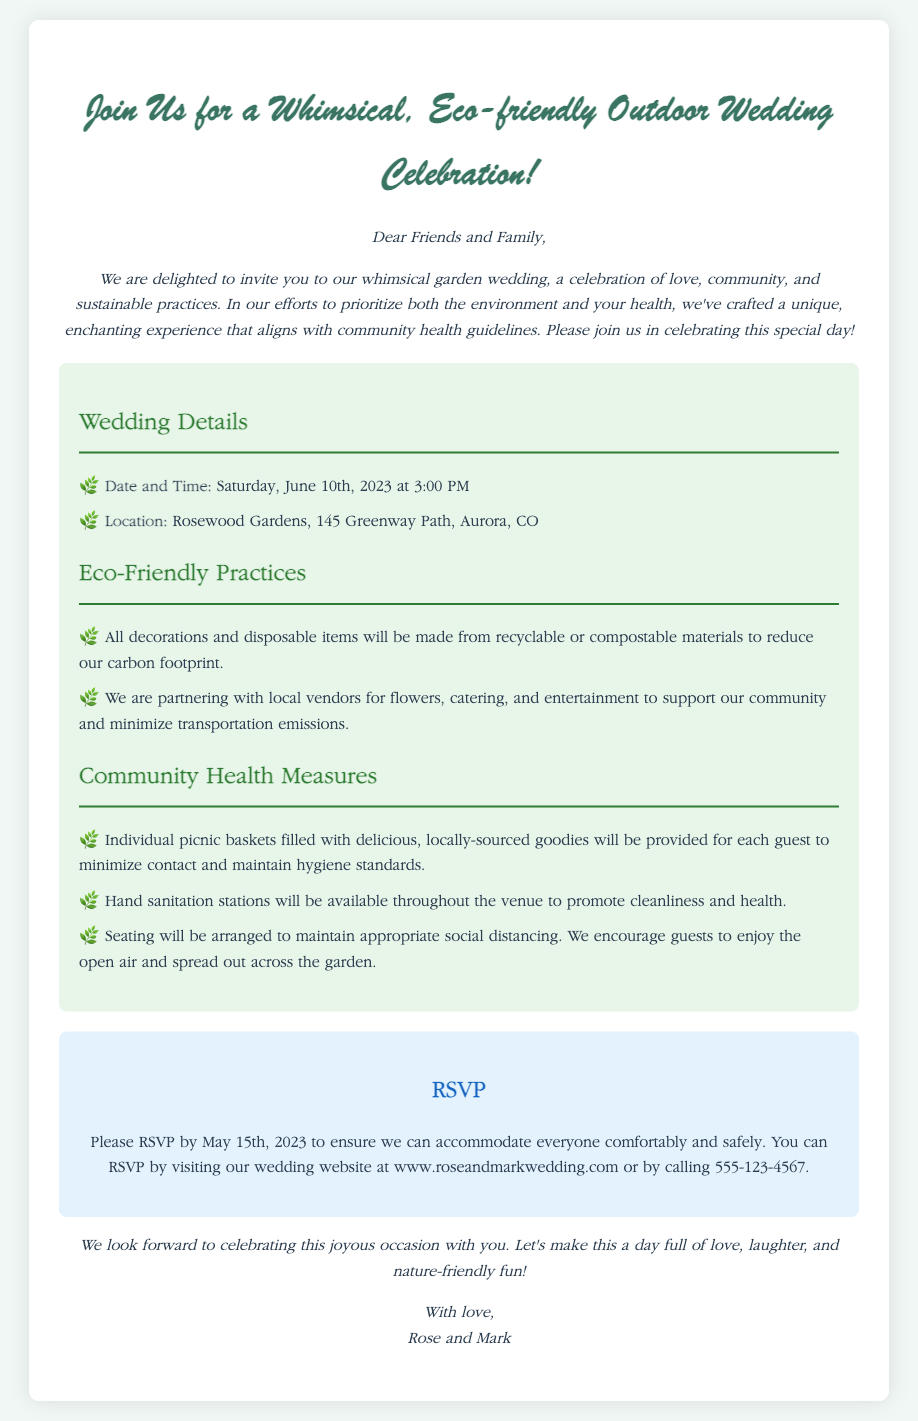what is the date of the wedding? The specific date mentioned in the invitation is the day of the wedding.
Answer: Saturday, June 10th, 2023 what time does the wedding start? The invitation states the starting time for the wedding ceremony.
Answer: 3:00 PM where is the wedding located? The invitation provides the full address where the wedding will take place.
Answer: Rosewood Gardens, 145 Greenway Path, Aurora, CO what type of food will be provided? The invitation describes the food arrangements that have been made for guests.
Answer: Individual picnic baskets what measures are being taken for community health? The invitation lists the specific actions taken to ensure the health and safety of guests.
Answer: Hand sanitation stations, social distancing seating which materials are used for decorations? The invitation details the kind of materials chosen to decorate the wedding venue.
Answer: Recyclable or compostable materials how should guests respond to the invitation? The invitation includes instructions on how guests can confirm their attendance.
Answer: RSVP by visiting the wedding website or calling what is the RSVP deadline? The invitation specifies the date by which guests should confirm their attendance.
Answer: May 15th, 2023 who are the hosts of the wedding? The invitation identifies the individuals who are getting married and inviting guests.
Answer: Rose and Mark 